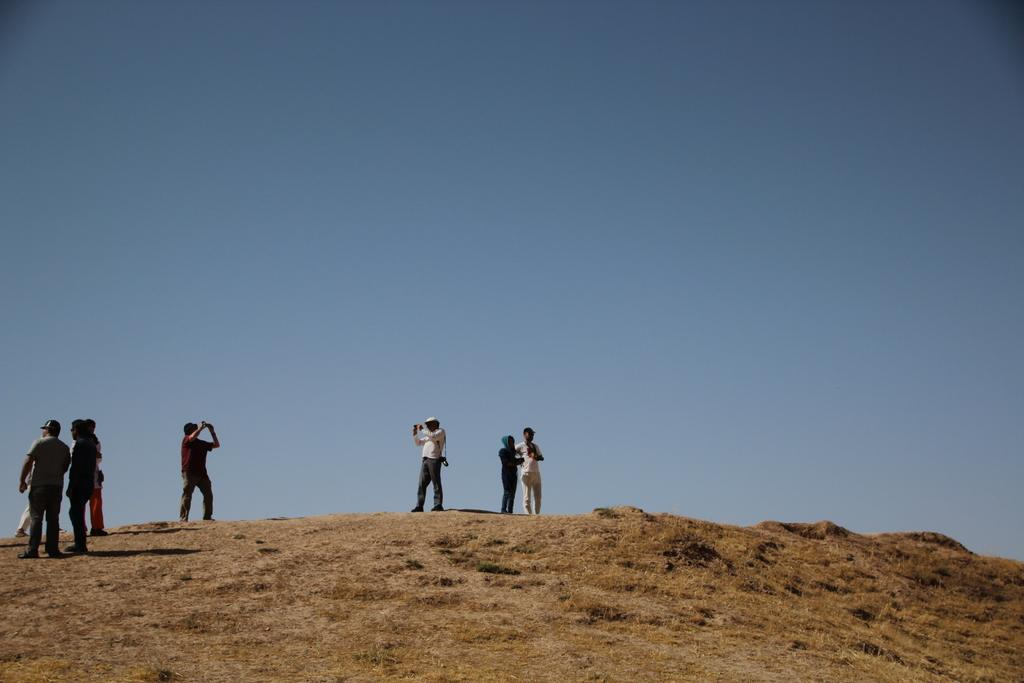What is happening on the ground in the image? There are persons on the ground in the image. What can be seen in the distance or background of the image? There is a sky visible in the background of the image. What type of zipper is being used by the persons in the image? There is no zipper present in the image; it only shows persons on the ground and a sky in the background. 